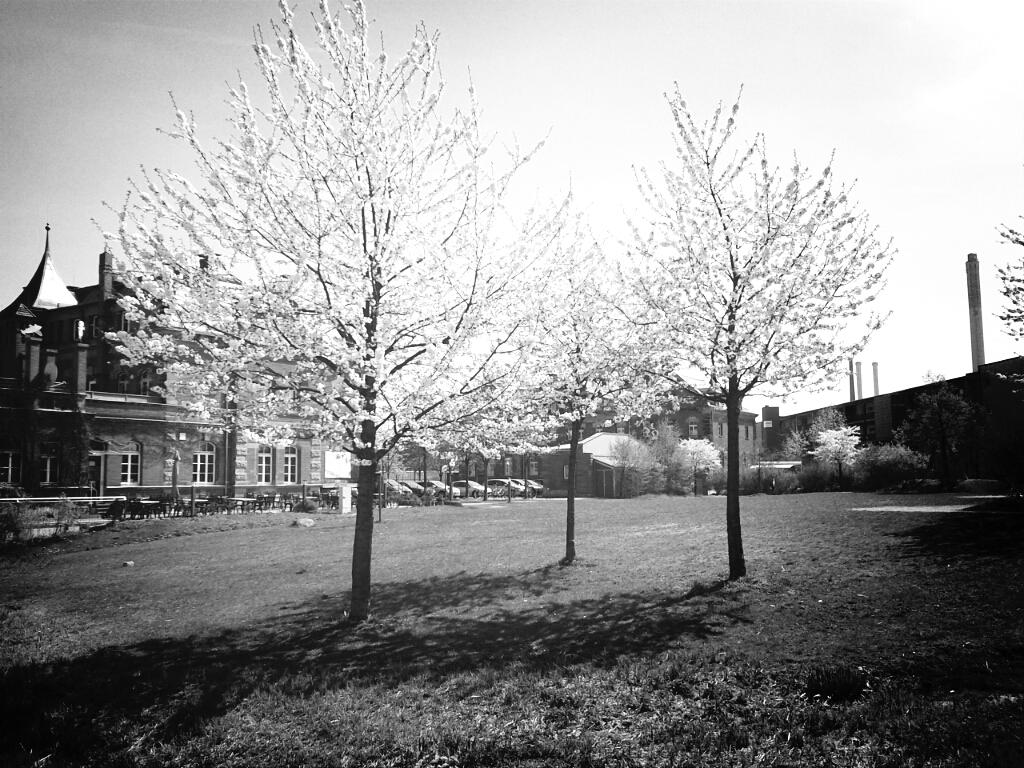What is located in the foreground of the image? There are trees in the foreground of the image. What can be seen in the background of the image? There are buildings, trees, vehicles, benches, grassland, and the sky visible in the background of the image. Can you tell me how many pins are holding the bridge in place in the image? There is no bridge present in the image, so there are no pins holding it in place. What type of battle is depicted in the image? There is no battle depicted in the image; it features trees, buildings, vehicles, benches, grassland, and the sky. 